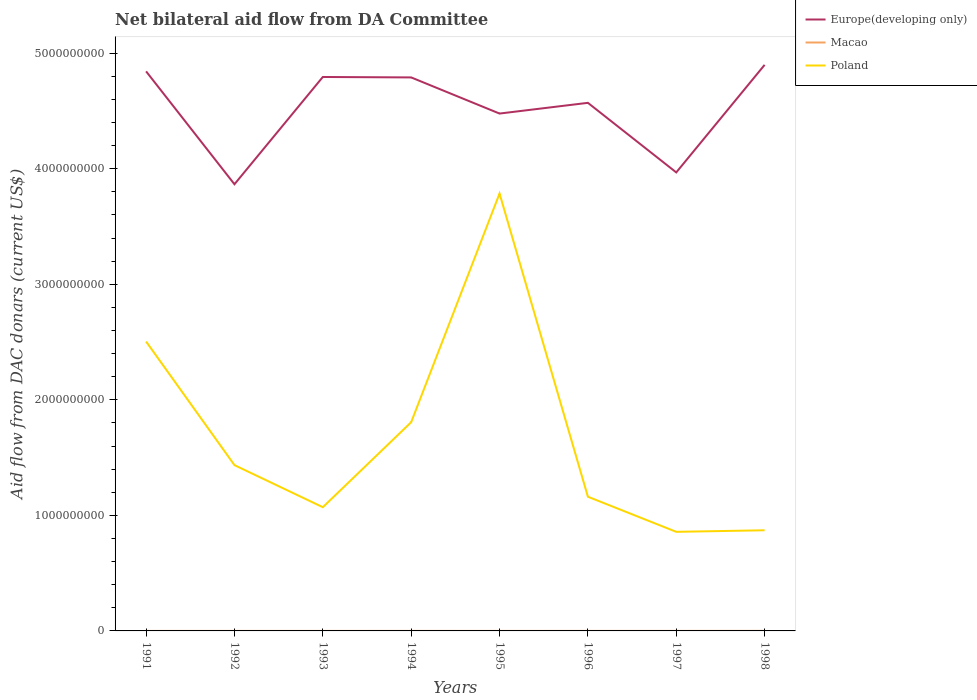How many different coloured lines are there?
Ensure brevity in your answer.  3. Does the line corresponding to Europe(developing only) intersect with the line corresponding to Poland?
Your answer should be compact. No. Across all years, what is the maximum aid flow in in Macao?
Provide a succinct answer. 1.20e+05. In which year was the aid flow in in Poland maximum?
Your answer should be very brief. 1997. What is the total aid flow in in Poland in the graph?
Ensure brevity in your answer.  -1.98e+09. What is the difference between the highest and the second highest aid flow in in Europe(developing only)?
Give a very brief answer. 1.03e+09. How many years are there in the graph?
Keep it short and to the point. 8. Are the values on the major ticks of Y-axis written in scientific E-notation?
Provide a short and direct response. No. Does the graph contain grids?
Give a very brief answer. No. How many legend labels are there?
Keep it short and to the point. 3. How are the legend labels stacked?
Ensure brevity in your answer.  Vertical. What is the title of the graph?
Offer a terse response. Net bilateral aid flow from DA Committee. Does "Bolivia" appear as one of the legend labels in the graph?
Your response must be concise. No. What is the label or title of the X-axis?
Your answer should be compact. Years. What is the label or title of the Y-axis?
Offer a very short reply. Aid flow from DAC donars (current US$). What is the Aid flow from DAC donars (current US$) in Europe(developing only) in 1991?
Provide a short and direct response. 4.84e+09. What is the Aid flow from DAC donars (current US$) in Poland in 1991?
Offer a very short reply. 2.50e+09. What is the Aid flow from DAC donars (current US$) in Europe(developing only) in 1992?
Keep it short and to the point. 3.87e+09. What is the Aid flow from DAC donars (current US$) in Macao in 1992?
Your answer should be very brief. 1.20e+05. What is the Aid flow from DAC donars (current US$) of Poland in 1992?
Give a very brief answer. 1.43e+09. What is the Aid flow from DAC donars (current US$) in Europe(developing only) in 1993?
Keep it short and to the point. 4.79e+09. What is the Aid flow from DAC donars (current US$) of Macao in 1993?
Keep it short and to the point. 1.50e+05. What is the Aid flow from DAC donars (current US$) of Poland in 1993?
Provide a succinct answer. 1.07e+09. What is the Aid flow from DAC donars (current US$) in Europe(developing only) in 1994?
Provide a succinct answer. 4.79e+09. What is the Aid flow from DAC donars (current US$) in Poland in 1994?
Provide a succinct answer. 1.81e+09. What is the Aid flow from DAC donars (current US$) in Europe(developing only) in 1995?
Provide a succinct answer. 4.48e+09. What is the Aid flow from DAC donars (current US$) of Poland in 1995?
Your answer should be very brief. 3.78e+09. What is the Aid flow from DAC donars (current US$) of Europe(developing only) in 1996?
Ensure brevity in your answer.  4.57e+09. What is the Aid flow from DAC donars (current US$) of Poland in 1996?
Keep it short and to the point. 1.16e+09. What is the Aid flow from DAC donars (current US$) in Europe(developing only) in 1997?
Your answer should be very brief. 3.97e+09. What is the Aid flow from DAC donars (current US$) of Poland in 1997?
Provide a short and direct response. 8.57e+08. What is the Aid flow from DAC donars (current US$) of Europe(developing only) in 1998?
Keep it short and to the point. 4.90e+09. What is the Aid flow from DAC donars (current US$) of Macao in 1998?
Keep it short and to the point. 5.00e+05. What is the Aid flow from DAC donars (current US$) in Poland in 1998?
Provide a succinct answer. 8.71e+08. Across all years, what is the maximum Aid flow from DAC donars (current US$) in Europe(developing only)?
Your answer should be very brief. 4.90e+09. Across all years, what is the maximum Aid flow from DAC donars (current US$) of Poland?
Your answer should be compact. 3.78e+09. Across all years, what is the minimum Aid flow from DAC donars (current US$) in Europe(developing only)?
Your response must be concise. 3.87e+09. Across all years, what is the minimum Aid flow from DAC donars (current US$) of Poland?
Give a very brief answer. 8.57e+08. What is the total Aid flow from DAC donars (current US$) in Europe(developing only) in the graph?
Offer a terse response. 3.62e+1. What is the total Aid flow from DAC donars (current US$) of Macao in the graph?
Ensure brevity in your answer.  1.90e+06. What is the total Aid flow from DAC donars (current US$) in Poland in the graph?
Ensure brevity in your answer.  1.35e+1. What is the difference between the Aid flow from DAC donars (current US$) of Europe(developing only) in 1991 and that in 1992?
Provide a succinct answer. 9.77e+08. What is the difference between the Aid flow from DAC donars (current US$) in Poland in 1991 and that in 1992?
Your answer should be compact. 1.07e+09. What is the difference between the Aid flow from DAC donars (current US$) in Europe(developing only) in 1991 and that in 1993?
Your response must be concise. 4.87e+07. What is the difference between the Aid flow from DAC donars (current US$) of Poland in 1991 and that in 1993?
Provide a short and direct response. 1.43e+09. What is the difference between the Aid flow from DAC donars (current US$) of Europe(developing only) in 1991 and that in 1994?
Ensure brevity in your answer.  5.25e+07. What is the difference between the Aid flow from DAC donars (current US$) in Macao in 1991 and that in 1994?
Ensure brevity in your answer.  -1.50e+05. What is the difference between the Aid flow from DAC donars (current US$) in Poland in 1991 and that in 1994?
Your answer should be very brief. 6.98e+08. What is the difference between the Aid flow from DAC donars (current US$) in Europe(developing only) in 1991 and that in 1995?
Make the answer very short. 3.65e+08. What is the difference between the Aid flow from DAC donars (current US$) of Poland in 1991 and that in 1995?
Give a very brief answer. -1.28e+09. What is the difference between the Aid flow from DAC donars (current US$) of Europe(developing only) in 1991 and that in 1996?
Make the answer very short. 2.72e+08. What is the difference between the Aid flow from DAC donars (current US$) in Poland in 1991 and that in 1996?
Offer a terse response. 1.34e+09. What is the difference between the Aid flow from DAC donars (current US$) of Europe(developing only) in 1991 and that in 1997?
Give a very brief answer. 8.74e+08. What is the difference between the Aid flow from DAC donars (current US$) of Macao in 1991 and that in 1997?
Your answer should be compact. -1.90e+05. What is the difference between the Aid flow from DAC donars (current US$) in Poland in 1991 and that in 1997?
Offer a terse response. 1.65e+09. What is the difference between the Aid flow from DAC donars (current US$) of Europe(developing only) in 1991 and that in 1998?
Provide a short and direct response. -5.60e+07. What is the difference between the Aid flow from DAC donars (current US$) in Macao in 1991 and that in 1998?
Provide a short and direct response. -3.80e+05. What is the difference between the Aid flow from DAC donars (current US$) of Poland in 1991 and that in 1998?
Ensure brevity in your answer.  1.63e+09. What is the difference between the Aid flow from DAC donars (current US$) of Europe(developing only) in 1992 and that in 1993?
Provide a succinct answer. -9.28e+08. What is the difference between the Aid flow from DAC donars (current US$) in Macao in 1992 and that in 1993?
Offer a terse response. -3.00e+04. What is the difference between the Aid flow from DAC donars (current US$) of Poland in 1992 and that in 1993?
Make the answer very short. 3.64e+08. What is the difference between the Aid flow from DAC donars (current US$) of Europe(developing only) in 1992 and that in 1994?
Your answer should be very brief. -9.24e+08. What is the difference between the Aid flow from DAC donars (current US$) in Poland in 1992 and that in 1994?
Your answer should be very brief. -3.72e+08. What is the difference between the Aid flow from DAC donars (current US$) of Europe(developing only) in 1992 and that in 1995?
Your answer should be compact. -6.12e+08. What is the difference between the Aid flow from DAC donars (current US$) in Macao in 1992 and that in 1995?
Give a very brief answer. -2.00e+04. What is the difference between the Aid flow from DAC donars (current US$) in Poland in 1992 and that in 1995?
Offer a terse response. -2.35e+09. What is the difference between the Aid flow from DAC donars (current US$) in Europe(developing only) in 1992 and that in 1996?
Provide a succinct answer. -7.04e+08. What is the difference between the Aid flow from DAC donars (current US$) in Macao in 1992 and that in 1996?
Your answer should be very brief. -1.70e+05. What is the difference between the Aid flow from DAC donars (current US$) in Poland in 1992 and that in 1996?
Make the answer very short. 2.73e+08. What is the difference between the Aid flow from DAC donars (current US$) in Europe(developing only) in 1992 and that in 1997?
Your answer should be compact. -1.02e+08. What is the difference between the Aid flow from DAC donars (current US$) of Poland in 1992 and that in 1997?
Your answer should be compact. 5.77e+08. What is the difference between the Aid flow from DAC donars (current US$) of Europe(developing only) in 1992 and that in 1998?
Your answer should be very brief. -1.03e+09. What is the difference between the Aid flow from DAC donars (current US$) of Macao in 1992 and that in 1998?
Keep it short and to the point. -3.80e+05. What is the difference between the Aid flow from DAC donars (current US$) in Poland in 1992 and that in 1998?
Make the answer very short. 5.64e+08. What is the difference between the Aid flow from DAC donars (current US$) of Europe(developing only) in 1993 and that in 1994?
Provide a short and direct response. 3.82e+06. What is the difference between the Aid flow from DAC donars (current US$) of Poland in 1993 and that in 1994?
Give a very brief answer. -7.36e+08. What is the difference between the Aid flow from DAC donars (current US$) of Europe(developing only) in 1993 and that in 1995?
Your answer should be compact. 3.16e+08. What is the difference between the Aid flow from DAC donars (current US$) of Poland in 1993 and that in 1995?
Your response must be concise. -2.71e+09. What is the difference between the Aid flow from DAC donars (current US$) of Europe(developing only) in 1993 and that in 1996?
Provide a short and direct response. 2.24e+08. What is the difference between the Aid flow from DAC donars (current US$) of Macao in 1993 and that in 1996?
Your answer should be very brief. -1.40e+05. What is the difference between the Aid flow from DAC donars (current US$) in Poland in 1993 and that in 1996?
Make the answer very short. -9.06e+07. What is the difference between the Aid flow from DAC donars (current US$) of Europe(developing only) in 1993 and that in 1997?
Offer a terse response. 8.26e+08. What is the difference between the Aid flow from DAC donars (current US$) of Macao in 1993 and that in 1997?
Make the answer very short. -1.60e+05. What is the difference between the Aid flow from DAC donars (current US$) of Poland in 1993 and that in 1997?
Keep it short and to the point. 2.13e+08. What is the difference between the Aid flow from DAC donars (current US$) in Europe(developing only) in 1993 and that in 1998?
Your answer should be very brief. -1.05e+08. What is the difference between the Aid flow from DAC donars (current US$) of Macao in 1993 and that in 1998?
Provide a short and direct response. -3.50e+05. What is the difference between the Aid flow from DAC donars (current US$) in Poland in 1993 and that in 1998?
Give a very brief answer. 2.00e+08. What is the difference between the Aid flow from DAC donars (current US$) of Europe(developing only) in 1994 and that in 1995?
Your answer should be compact. 3.13e+08. What is the difference between the Aid flow from DAC donars (current US$) of Macao in 1994 and that in 1995?
Offer a terse response. 1.30e+05. What is the difference between the Aid flow from DAC donars (current US$) of Poland in 1994 and that in 1995?
Give a very brief answer. -1.98e+09. What is the difference between the Aid flow from DAC donars (current US$) in Europe(developing only) in 1994 and that in 1996?
Make the answer very short. 2.20e+08. What is the difference between the Aid flow from DAC donars (current US$) of Poland in 1994 and that in 1996?
Your response must be concise. 6.45e+08. What is the difference between the Aid flow from DAC donars (current US$) of Europe(developing only) in 1994 and that in 1997?
Your answer should be very brief. 8.22e+08. What is the difference between the Aid flow from DAC donars (current US$) of Poland in 1994 and that in 1997?
Provide a succinct answer. 9.49e+08. What is the difference between the Aid flow from DAC donars (current US$) in Europe(developing only) in 1994 and that in 1998?
Keep it short and to the point. -1.09e+08. What is the difference between the Aid flow from DAC donars (current US$) of Poland in 1994 and that in 1998?
Make the answer very short. 9.35e+08. What is the difference between the Aid flow from DAC donars (current US$) of Europe(developing only) in 1995 and that in 1996?
Your response must be concise. -9.28e+07. What is the difference between the Aid flow from DAC donars (current US$) of Poland in 1995 and that in 1996?
Offer a terse response. 2.62e+09. What is the difference between the Aid flow from DAC donars (current US$) of Europe(developing only) in 1995 and that in 1997?
Provide a succinct answer. 5.09e+08. What is the difference between the Aid flow from DAC donars (current US$) of Poland in 1995 and that in 1997?
Ensure brevity in your answer.  2.93e+09. What is the difference between the Aid flow from DAC donars (current US$) of Europe(developing only) in 1995 and that in 1998?
Provide a succinct answer. -4.21e+08. What is the difference between the Aid flow from DAC donars (current US$) of Macao in 1995 and that in 1998?
Provide a short and direct response. -3.60e+05. What is the difference between the Aid flow from DAC donars (current US$) in Poland in 1995 and that in 1998?
Make the answer very short. 2.91e+09. What is the difference between the Aid flow from DAC donars (current US$) in Europe(developing only) in 1996 and that in 1997?
Your answer should be compact. 6.02e+08. What is the difference between the Aid flow from DAC donars (current US$) of Poland in 1996 and that in 1997?
Provide a short and direct response. 3.04e+08. What is the difference between the Aid flow from DAC donars (current US$) of Europe(developing only) in 1996 and that in 1998?
Provide a short and direct response. -3.28e+08. What is the difference between the Aid flow from DAC donars (current US$) of Poland in 1996 and that in 1998?
Provide a succinct answer. 2.90e+08. What is the difference between the Aid flow from DAC donars (current US$) of Europe(developing only) in 1997 and that in 1998?
Your answer should be very brief. -9.30e+08. What is the difference between the Aid flow from DAC donars (current US$) in Macao in 1997 and that in 1998?
Offer a terse response. -1.90e+05. What is the difference between the Aid flow from DAC donars (current US$) in Poland in 1997 and that in 1998?
Give a very brief answer. -1.35e+07. What is the difference between the Aid flow from DAC donars (current US$) in Europe(developing only) in 1991 and the Aid flow from DAC donars (current US$) in Macao in 1992?
Ensure brevity in your answer.  4.84e+09. What is the difference between the Aid flow from DAC donars (current US$) of Europe(developing only) in 1991 and the Aid flow from DAC donars (current US$) of Poland in 1992?
Offer a terse response. 3.41e+09. What is the difference between the Aid flow from DAC donars (current US$) of Macao in 1991 and the Aid flow from DAC donars (current US$) of Poland in 1992?
Make the answer very short. -1.43e+09. What is the difference between the Aid flow from DAC donars (current US$) in Europe(developing only) in 1991 and the Aid flow from DAC donars (current US$) in Macao in 1993?
Provide a short and direct response. 4.84e+09. What is the difference between the Aid flow from DAC donars (current US$) of Europe(developing only) in 1991 and the Aid flow from DAC donars (current US$) of Poland in 1993?
Provide a short and direct response. 3.77e+09. What is the difference between the Aid flow from DAC donars (current US$) of Macao in 1991 and the Aid flow from DAC donars (current US$) of Poland in 1993?
Your answer should be very brief. -1.07e+09. What is the difference between the Aid flow from DAC donars (current US$) in Europe(developing only) in 1991 and the Aid flow from DAC donars (current US$) in Macao in 1994?
Your answer should be very brief. 4.84e+09. What is the difference between the Aid flow from DAC donars (current US$) in Europe(developing only) in 1991 and the Aid flow from DAC donars (current US$) in Poland in 1994?
Offer a terse response. 3.04e+09. What is the difference between the Aid flow from DAC donars (current US$) in Macao in 1991 and the Aid flow from DAC donars (current US$) in Poland in 1994?
Offer a terse response. -1.81e+09. What is the difference between the Aid flow from DAC donars (current US$) in Europe(developing only) in 1991 and the Aid flow from DAC donars (current US$) in Macao in 1995?
Your answer should be very brief. 4.84e+09. What is the difference between the Aid flow from DAC donars (current US$) in Europe(developing only) in 1991 and the Aid flow from DAC donars (current US$) in Poland in 1995?
Your answer should be compact. 1.06e+09. What is the difference between the Aid flow from DAC donars (current US$) of Macao in 1991 and the Aid flow from DAC donars (current US$) of Poland in 1995?
Give a very brief answer. -3.78e+09. What is the difference between the Aid flow from DAC donars (current US$) in Europe(developing only) in 1991 and the Aid flow from DAC donars (current US$) in Macao in 1996?
Your answer should be compact. 4.84e+09. What is the difference between the Aid flow from DAC donars (current US$) of Europe(developing only) in 1991 and the Aid flow from DAC donars (current US$) of Poland in 1996?
Offer a very short reply. 3.68e+09. What is the difference between the Aid flow from DAC donars (current US$) of Macao in 1991 and the Aid flow from DAC donars (current US$) of Poland in 1996?
Make the answer very short. -1.16e+09. What is the difference between the Aid flow from DAC donars (current US$) of Europe(developing only) in 1991 and the Aid flow from DAC donars (current US$) of Macao in 1997?
Your answer should be very brief. 4.84e+09. What is the difference between the Aid flow from DAC donars (current US$) of Europe(developing only) in 1991 and the Aid flow from DAC donars (current US$) of Poland in 1997?
Provide a succinct answer. 3.98e+09. What is the difference between the Aid flow from DAC donars (current US$) of Macao in 1991 and the Aid flow from DAC donars (current US$) of Poland in 1997?
Make the answer very short. -8.57e+08. What is the difference between the Aid flow from DAC donars (current US$) of Europe(developing only) in 1991 and the Aid flow from DAC donars (current US$) of Macao in 1998?
Your answer should be very brief. 4.84e+09. What is the difference between the Aid flow from DAC donars (current US$) in Europe(developing only) in 1991 and the Aid flow from DAC donars (current US$) in Poland in 1998?
Offer a very short reply. 3.97e+09. What is the difference between the Aid flow from DAC donars (current US$) of Macao in 1991 and the Aid flow from DAC donars (current US$) of Poland in 1998?
Provide a succinct answer. -8.71e+08. What is the difference between the Aid flow from DAC donars (current US$) of Europe(developing only) in 1992 and the Aid flow from DAC donars (current US$) of Macao in 1993?
Give a very brief answer. 3.87e+09. What is the difference between the Aid flow from DAC donars (current US$) in Europe(developing only) in 1992 and the Aid flow from DAC donars (current US$) in Poland in 1993?
Make the answer very short. 2.79e+09. What is the difference between the Aid flow from DAC donars (current US$) of Macao in 1992 and the Aid flow from DAC donars (current US$) of Poland in 1993?
Your response must be concise. -1.07e+09. What is the difference between the Aid flow from DAC donars (current US$) in Europe(developing only) in 1992 and the Aid flow from DAC donars (current US$) in Macao in 1994?
Give a very brief answer. 3.86e+09. What is the difference between the Aid flow from DAC donars (current US$) in Europe(developing only) in 1992 and the Aid flow from DAC donars (current US$) in Poland in 1994?
Provide a succinct answer. 2.06e+09. What is the difference between the Aid flow from DAC donars (current US$) in Macao in 1992 and the Aid flow from DAC donars (current US$) in Poland in 1994?
Provide a succinct answer. -1.81e+09. What is the difference between the Aid flow from DAC donars (current US$) of Europe(developing only) in 1992 and the Aid flow from DAC donars (current US$) of Macao in 1995?
Your response must be concise. 3.87e+09. What is the difference between the Aid flow from DAC donars (current US$) of Europe(developing only) in 1992 and the Aid flow from DAC donars (current US$) of Poland in 1995?
Your answer should be very brief. 8.05e+07. What is the difference between the Aid flow from DAC donars (current US$) in Macao in 1992 and the Aid flow from DAC donars (current US$) in Poland in 1995?
Ensure brevity in your answer.  -3.78e+09. What is the difference between the Aid flow from DAC donars (current US$) of Europe(developing only) in 1992 and the Aid flow from DAC donars (current US$) of Macao in 1996?
Make the answer very short. 3.86e+09. What is the difference between the Aid flow from DAC donars (current US$) of Europe(developing only) in 1992 and the Aid flow from DAC donars (current US$) of Poland in 1996?
Offer a terse response. 2.70e+09. What is the difference between the Aid flow from DAC donars (current US$) of Macao in 1992 and the Aid flow from DAC donars (current US$) of Poland in 1996?
Your answer should be compact. -1.16e+09. What is the difference between the Aid flow from DAC donars (current US$) in Europe(developing only) in 1992 and the Aid flow from DAC donars (current US$) in Macao in 1997?
Offer a very short reply. 3.86e+09. What is the difference between the Aid flow from DAC donars (current US$) of Europe(developing only) in 1992 and the Aid flow from DAC donars (current US$) of Poland in 1997?
Ensure brevity in your answer.  3.01e+09. What is the difference between the Aid flow from DAC donars (current US$) of Macao in 1992 and the Aid flow from DAC donars (current US$) of Poland in 1997?
Ensure brevity in your answer.  -8.57e+08. What is the difference between the Aid flow from DAC donars (current US$) of Europe(developing only) in 1992 and the Aid flow from DAC donars (current US$) of Macao in 1998?
Your response must be concise. 3.86e+09. What is the difference between the Aid flow from DAC donars (current US$) in Europe(developing only) in 1992 and the Aid flow from DAC donars (current US$) in Poland in 1998?
Keep it short and to the point. 2.99e+09. What is the difference between the Aid flow from DAC donars (current US$) in Macao in 1992 and the Aid flow from DAC donars (current US$) in Poland in 1998?
Offer a terse response. -8.71e+08. What is the difference between the Aid flow from DAC donars (current US$) in Europe(developing only) in 1993 and the Aid flow from DAC donars (current US$) in Macao in 1994?
Offer a very short reply. 4.79e+09. What is the difference between the Aid flow from DAC donars (current US$) of Europe(developing only) in 1993 and the Aid flow from DAC donars (current US$) of Poland in 1994?
Your response must be concise. 2.99e+09. What is the difference between the Aid flow from DAC donars (current US$) in Macao in 1993 and the Aid flow from DAC donars (current US$) in Poland in 1994?
Offer a very short reply. -1.81e+09. What is the difference between the Aid flow from DAC donars (current US$) of Europe(developing only) in 1993 and the Aid flow from DAC donars (current US$) of Macao in 1995?
Your response must be concise. 4.79e+09. What is the difference between the Aid flow from DAC donars (current US$) in Europe(developing only) in 1993 and the Aid flow from DAC donars (current US$) in Poland in 1995?
Ensure brevity in your answer.  1.01e+09. What is the difference between the Aid flow from DAC donars (current US$) of Macao in 1993 and the Aid flow from DAC donars (current US$) of Poland in 1995?
Provide a succinct answer. -3.78e+09. What is the difference between the Aid flow from DAC donars (current US$) in Europe(developing only) in 1993 and the Aid flow from DAC donars (current US$) in Macao in 1996?
Give a very brief answer. 4.79e+09. What is the difference between the Aid flow from DAC donars (current US$) in Europe(developing only) in 1993 and the Aid flow from DAC donars (current US$) in Poland in 1996?
Keep it short and to the point. 3.63e+09. What is the difference between the Aid flow from DAC donars (current US$) in Macao in 1993 and the Aid flow from DAC donars (current US$) in Poland in 1996?
Give a very brief answer. -1.16e+09. What is the difference between the Aid flow from DAC donars (current US$) in Europe(developing only) in 1993 and the Aid flow from DAC donars (current US$) in Macao in 1997?
Provide a succinct answer. 4.79e+09. What is the difference between the Aid flow from DAC donars (current US$) in Europe(developing only) in 1993 and the Aid flow from DAC donars (current US$) in Poland in 1997?
Give a very brief answer. 3.94e+09. What is the difference between the Aid flow from DAC donars (current US$) of Macao in 1993 and the Aid flow from DAC donars (current US$) of Poland in 1997?
Keep it short and to the point. -8.57e+08. What is the difference between the Aid flow from DAC donars (current US$) in Europe(developing only) in 1993 and the Aid flow from DAC donars (current US$) in Macao in 1998?
Provide a short and direct response. 4.79e+09. What is the difference between the Aid flow from DAC donars (current US$) in Europe(developing only) in 1993 and the Aid flow from DAC donars (current US$) in Poland in 1998?
Offer a very short reply. 3.92e+09. What is the difference between the Aid flow from DAC donars (current US$) of Macao in 1993 and the Aid flow from DAC donars (current US$) of Poland in 1998?
Keep it short and to the point. -8.71e+08. What is the difference between the Aid flow from DAC donars (current US$) of Europe(developing only) in 1994 and the Aid flow from DAC donars (current US$) of Macao in 1995?
Your answer should be compact. 4.79e+09. What is the difference between the Aid flow from DAC donars (current US$) in Europe(developing only) in 1994 and the Aid flow from DAC donars (current US$) in Poland in 1995?
Your answer should be compact. 1.00e+09. What is the difference between the Aid flow from DAC donars (current US$) in Macao in 1994 and the Aid flow from DAC donars (current US$) in Poland in 1995?
Keep it short and to the point. -3.78e+09. What is the difference between the Aid flow from DAC donars (current US$) in Europe(developing only) in 1994 and the Aid flow from DAC donars (current US$) in Macao in 1996?
Your answer should be compact. 4.79e+09. What is the difference between the Aid flow from DAC donars (current US$) of Europe(developing only) in 1994 and the Aid flow from DAC donars (current US$) of Poland in 1996?
Give a very brief answer. 3.63e+09. What is the difference between the Aid flow from DAC donars (current US$) of Macao in 1994 and the Aid flow from DAC donars (current US$) of Poland in 1996?
Provide a short and direct response. -1.16e+09. What is the difference between the Aid flow from DAC donars (current US$) in Europe(developing only) in 1994 and the Aid flow from DAC donars (current US$) in Macao in 1997?
Your response must be concise. 4.79e+09. What is the difference between the Aid flow from DAC donars (current US$) of Europe(developing only) in 1994 and the Aid flow from DAC donars (current US$) of Poland in 1997?
Your answer should be very brief. 3.93e+09. What is the difference between the Aid flow from DAC donars (current US$) in Macao in 1994 and the Aid flow from DAC donars (current US$) in Poland in 1997?
Provide a succinct answer. -8.57e+08. What is the difference between the Aid flow from DAC donars (current US$) of Europe(developing only) in 1994 and the Aid flow from DAC donars (current US$) of Macao in 1998?
Your answer should be very brief. 4.79e+09. What is the difference between the Aid flow from DAC donars (current US$) in Europe(developing only) in 1994 and the Aid flow from DAC donars (current US$) in Poland in 1998?
Your answer should be compact. 3.92e+09. What is the difference between the Aid flow from DAC donars (current US$) of Macao in 1994 and the Aid flow from DAC donars (current US$) of Poland in 1998?
Your answer should be compact. -8.71e+08. What is the difference between the Aid flow from DAC donars (current US$) in Europe(developing only) in 1995 and the Aid flow from DAC donars (current US$) in Macao in 1996?
Give a very brief answer. 4.48e+09. What is the difference between the Aid flow from DAC donars (current US$) of Europe(developing only) in 1995 and the Aid flow from DAC donars (current US$) of Poland in 1996?
Offer a terse response. 3.32e+09. What is the difference between the Aid flow from DAC donars (current US$) of Macao in 1995 and the Aid flow from DAC donars (current US$) of Poland in 1996?
Keep it short and to the point. -1.16e+09. What is the difference between the Aid flow from DAC donars (current US$) of Europe(developing only) in 1995 and the Aid flow from DAC donars (current US$) of Macao in 1997?
Offer a terse response. 4.48e+09. What is the difference between the Aid flow from DAC donars (current US$) in Europe(developing only) in 1995 and the Aid flow from DAC donars (current US$) in Poland in 1997?
Give a very brief answer. 3.62e+09. What is the difference between the Aid flow from DAC donars (current US$) of Macao in 1995 and the Aid flow from DAC donars (current US$) of Poland in 1997?
Ensure brevity in your answer.  -8.57e+08. What is the difference between the Aid flow from DAC donars (current US$) of Europe(developing only) in 1995 and the Aid flow from DAC donars (current US$) of Macao in 1998?
Make the answer very short. 4.48e+09. What is the difference between the Aid flow from DAC donars (current US$) of Europe(developing only) in 1995 and the Aid flow from DAC donars (current US$) of Poland in 1998?
Your answer should be compact. 3.61e+09. What is the difference between the Aid flow from DAC donars (current US$) in Macao in 1995 and the Aid flow from DAC donars (current US$) in Poland in 1998?
Keep it short and to the point. -8.71e+08. What is the difference between the Aid flow from DAC donars (current US$) of Europe(developing only) in 1996 and the Aid flow from DAC donars (current US$) of Macao in 1997?
Offer a terse response. 4.57e+09. What is the difference between the Aid flow from DAC donars (current US$) of Europe(developing only) in 1996 and the Aid flow from DAC donars (current US$) of Poland in 1997?
Ensure brevity in your answer.  3.71e+09. What is the difference between the Aid flow from DAC donars (current US$) of Macao in 1996 and the Aid flow from DAC donars (current US$) of Poland in 1997?
Your answer should be compact. -8.57e+08. What is the difference between the Aid flow from DAC donars (current US$) in Europe(developing only) in 1996 and the Aid flow from DAC donars (current US$) in Macao in 1998?
Provide a succinct answer. 4.57e+09. What is the difference between the Aid flow from DAC donars (current US$) of Europe(developing only) in 1996 and the Aid flow from DAC donars (current US$) of Poland in 1998?
Your answer should be very brief. 3.70e+09. What is the difference between the Aid flow from DAC donars (current US$) of Macao in 1996 and the Aid flow from DAC donars (current US$) of Poland in 1998?
Make the answer very short. -8.71e+08. What is the difference between the Aid flow from DAC donars (current US$) in Europe(developing only) in 1997 and the Aid flow from DAC donars (current US$) in Macao in 1998?
Offer a very short reply. 3.97e+09. What is the difference between the Aid flow from DAC donars (current US$) of Europe(developing only) in 1997 and the Aid flow from DAC donars (current US$) of Poland in 1998?
Your answer should be very brief. 3.10e+09. What is the difference between the Aid flow from DAC donars (current US$) in Macao in 1997 and the Aid flow from DAC donars (current US$) in Poland in 1998?
Your response must be concise. -8.71e+08. What is the average Aid flow from DAC donars (current US$) in Europe(developing only) per year?
Your answer should be very brief. 4.53e+09. What is the average Aid flow from DAC donars (current US$) in Macao per year?
Your answer should be very brief. 2.38e+05. What is the average Aid flow from DAC donars (current US$) of Poland per year?
Provide a succinct answer. 1.69e+09. In the year 1991, what is the difference between the Aid flow from DAC donars (current US$) of Europe(developing only) and Aid flow from DAC donars (current US$) of Macao?
Provide a short and direct response. 4.84e+09. In the year 1991, what is the difference between the Aid flow from DAC donars (current US$) of Europe(developing only) and Aid flow from DAC donars (current US$) of Poland?
Offer a very short reply. 2.34e+09. In the year 1991, what is the difference between the Aid flow from DAC donars (current US$) of Macao and Aid flow from DAC donars (current US$) of Poland?
Provide a succinct answer. -2.50e+09. In the year 1992, what is the difference between the Aid flow from DAC donars (current US$) in Europe(developing only) and Aid flow from DAC donars (current US$) in Macao?
Provide a succinct answer. 3.87e+09. In the year 1992, what is the difference between the Aid flow from DAC donars (current US$) of Europe(developing only) and Aid flow from DAC donars (current US$) of Poland?
Keep it short and to the point. 2.43e+09. In the year 1992, what is the difference between the Aid flow from DAC donars (current US$) in Macao and Aid flow from DAC donars (current US$) in Poland?
Your answer should be very brief. -1.43e+09. In the year 1993, what is the difference between the Aid flow from DAC donars (current US$) in Europe(developing only) and Aid flow from DAC donars (current US$) in Macao?
Provide a succinct answer. 4.79e+09. In the year 1993, what is the difference between the Aid flow from DAC donars (current US$) in Europe(developing only) and Aid flow from DAC donars (current US$) in Poland?
Keep it short and to the point. 3.72e+09. In the year 1993, what is the difference between the Aid flow from DAC donars (current US$) of Macao and Aid flow from DAC donars (current US$) of Poland?
Your answer should be very brief. -1.07e+09. In the year 1994, what is the difference between the Aid flow from DAC donars (current US$) of Europe(developing only) and Aid flow from DAC donars (current US$) of Macao?
Keep it short and to the point. 4.79e+09. In the year 1994, what is the difference between the Aid flow from DAC donars (current US$) in Europe(developing only) and Aid flow from DAC donars (current US$) in Poland?
Make the answer very short. 2.98e+09. In the year 1994, what is the difference between the Aid flow from DAC donars (current US$) of Macao and Aid flow from DAC donars (current US$) of Poland?
Offer a terse response. -1.81e+09. In the year 1995, what is the difference between the Aid flow from DAC donars (current US$) of Europe(developing only) and Aid flow from DAC donars (current US$) of Macao?
Keep it short and to the point. 4.48e+09. In the year 1995, what is the difference between the Aid flow from DAC donars (current US$) in Europe(developing only) and Aid flow from DAC donars (current US$) in Poland?
Your response must be concise. 6.92e+08. In the year 1995, what is the difference between the Aid flow from DAC donars (current US$) in Macao and Aid flow from DAC donars (current US$) in Poland?
Your answer should be very brief. -3.78e+09. In the year 1996, what is the difference between the Aid flow from DAC donars (current US$) in Europe(developing only) and Aid flow from DAC donars (current US$) in Macao?
Keep it short and to the point. 4.57e+09. In the year 1996, what is the difference between the Aid flow from DAC donars (current US$) in Europe(developing only) and Aid flow from DAC donars (current US$) in Poland?
Offer a terse response. 3.41e+09. In the year 1996, what is the difference between the Aid flow from DAC donars (current US$) in Macao and Aid flow from DAC donars (current US$) in Poland?
Make the answer very short. -1.16e+09. In the year 1997, what is the difference between the Aid flow from DAC donars (current US$) of Europe(developing only) and Aid flow from DAC donars (current US$) of Macao?
Provide a succinct answer. 3.97e+09. In the year 1997, what is the difference between the Aid flow from DAC donars (current US$) in Europe(developing only) and Aid flow from DAC donars (current US$) in Poland?
Make the answer very short. 3.11e+09. In the year 1997, what is the difference between the Aid flow from DAC donars (current US$) of Macao and Aid flow from DAC donars (current US$) of Poland?
Offer a terse response. -8.57e+08. In the year 1998, what is the difference between the Aid flow from DAC donars (current US$) in Europe(developing only) and Aid flow from DAC donars (current US$) in Macao?
Ensure brevity in your answer.  4.90e+09. In the year 1998, what is the difference between the Aid flow from DAC donars (current US$) in Europe(developing only) and Aid flow from DAC donars (current US$) in Poland?
Give a very brief answer. 4.03e+09. In the year 1998, what is the difference between the Aid flow from DAC donars (current US$) in Macao and Aid flow from DAC donars (current US$) in Poland?
Ensure brevity in your answer.  -8.70e+08. What is the ratio of the Aid flow from DAC donars (current US$) of Europe(developing only) in 1991 to that in 1992?
Offer a very short reply. 1.25. What is the ratio of the Aid flow from DAC donars (current US$) of Poland in 1991 to that in 1992?
Give a very brief answer. 1.75. What is the ratio of the Aid flow from DAC donars (current US$) in Europe(developing only) in 1991 to that in 1993?
Make the answer very short. 1.01. What is the ratio of the Aid flow from DAC donars (current US$) in Macao in 1991 to that in 1993?
Your answer should be compact. 0.8. What is the ratio of the Aid flow from DAC donars (current US$) in Poland in 1991 to that in 1993?
Keep it short and to the point. 2.34. What is the ratio of the Aid flow from DAC donars (current US$) in Europe(developing only) in 1991 to that in 1994?
Offer a terse response. 1.01. What is the ratio of the Aid flow from DAC donars (current US$) in Macao in 1991 to that in 1994?
Ensure brevity in your answer.  0.44. What is the ratio of the Aid flow from DAC donars (current US$) in Poland in 1991 to that in 1994?
Offer a terse response. 1.39. What is the ratio of the Aid flow from DAC donars (current US$) of Europe(developing only) in 1991 to that in 1995?
Give a very brief answer. 1.08. What is the ratio of the Aid flow from DAC donars (current US$) in Macao in 1991 to that in 1995?
Give a very brief answer. 0.86. What is the ratio of the Aid flow from DAC donars (current US$) in Poland in 1991 to that in 1995?
Make the answer very short. 0.66. What is the ratio of the Aid flow from DAC donars (current US$) in Europe(developing only) in 1991 to that in 1996?
Ensure brevity in your answer.  1.06. What is the ratio of the Aid flow from DAC donars (current US$) in Macao in 1991 to that in 1996?
Provide a succinct answer. 0.41. What is the ratio of the Aid flow from DAC donars (current US$) in Poland in 1991 to that in 1996?
Keep it short and to the point. 2.16. What is the ratio of the Aid flow from DAC donars (current US$) of Europe(developing only) in 1991 to that in 1997?
Give a very brief answer. 1.22. What is the ratio of the Aid flow from DAC donars (current US$) in Macao in 1991 to that in 1997?
Keep it short and to the point. 0.39. What is the ratio of the Aid flow from DAC donars (current US$) of Poland in 1991 to that in 1997?
Provide a succinct answer. 2.92. What is the ratio of the Aid flow from DAC donars (current US$) of Europe(developing only) in 1991 to that in 1998?
Offer a very short reply. 0.99. What is the ratio of the Aid flow from DAC donars (current US$) in Macao in 1991 to that in 1998?
Your response must be concise. 0.24. What is the ratio of the Aid flow from DAC donars (current US$) in Poland in 1991 to that in 1998?
Your answer should be compact. 2.88. What is the ratio of the Aid flow from DAC donars (current US$) of Europe(developing only) in 1992 to that in 1993?
Keep it short and to the point. 0.81. What is the ratio of the Aid flow from DAC donars (current US$) of Macao in 1992 to that in 1993?
Ensure brevity in your answer.  0.8. What is the ratio of the Aid flow from DAC donars (current US$) in Poland in 1992 to that in 1993?
Make the answer very short. 1.34. What is the ratio of the Aid flow from DAC donars (current US$) of Europe(developing only) in 1992 to that in 1994?
Keep it short and to the point. 0.81. What is the ratio of the Aid flow from DAC donars (current US$) in Macao in 1992 to that in 1994?
Offer a terse response. 0.44. What is the ratio of the Aid flow from DAC donars (current US$) of Poland in 1992 to that in 1994?
Your answer should be compact. 0.79. What is the ratio of the Aid flow from DAC donars (current US$) of Europe(developing only) in 1992 to that in 1995?
Provide a succinct answer. 0.86. What is the ratio of the Aid flow from DAC donars (current US$) in Poland in 1992 to that in 1995?
Your answer should be compact. 0.38. What is the ratio of the Aid flow from DAC donars (current US$) of Europe(developing only) in 1992 to that in 1996?
Give a very brief answer. 0.85. What is the ratio of the Aid flow from DAC donars (current US$) of Macao in 1992 to that in 1996?
Make the answer very short. 0.41. What is the ratio of the Aid flow from DAC donars (current US$) in Poland in 1992 to that in 1996?
Keep it short and to the point. 1.24. What is the ratio of the Aid flow from DAC donars (current US$) in Europe(developing only) in 1992 to that in 1997?
Offer a terse response. 0.97. What is the ratio of the Aid flow from DAC donars (current US$) in Macao in 1992 to that in 1997?
Give a very brief answer. 0.39. What is the ratio of the Aid flow from DAC donars (current US$) in Poland in 1992 to that in 1997?
Give a very brief answer. 1.67. What is the ratio of the Aid flow from DAC donars (current US$) of Europe(developing only) in 1992 to that in 1998?
Provide a succinct answer. 0.79. What is the ratio of the Aid flow from DAC donars (current US$) of Macao in 1992 to that in 1998?
Give a very brief answer. 0.24. What is the ratio of the Aid flow from DAC donars (current US$) of Poland in 1992 to that in 1998?
Keep it short and to the point. 1.65. What is the ratio of the Aid flow from DAC donars (current US$) in Europe(developing only) in 1993 to that in 1994?
Keep it short and to the point. 1. What is the ratio of the Aid flow from DAC donars (current US$) in Macao in 1993 to that in 1994?
Ensure brevity in your answer.  0.56. What is the ratio of the Aid flow from DAC donars (current US$) in Poland in 1993 to that in 1994?
Offer a very short reply. 0.59. What is the ratio of the Aid flow from DAC donars (current US$) of Europe(developing only) in 1993 to that in 1995?
Your answer should be very brief. 1.07. What is the ratio of the Aid flow from DAC donars (current US$) in Macao in 1993 to that in 1995?
Keep it short and to the point. 1.07. What is the ratio of the Aid flow from DAC donars (current US$) of Poland in 1993 to that in 1995?
Provide a succinct answer. 0.28. What is the ratio of the Aid flow from DAC donars (current US$) in Europe(developing only) in 1993 to that in 1996?
Make the answer very short. 1.05. What is the ratio of the Aid flow from DAC donars (current US$) in Macao in 1993 to that in 1996?
Offer a terse response. 0.52. What is the ratio of the Aid flow from DAC donars (current US$) in Poland in 1993 to that in 1996?
Provide a succinct answer. 0.92. What is the ratio of the Aid flow from DAC donars (current US$) in Europe(developing only) in 1993 to that in 1997?
Ensure brevity in your answer.  1.21. What is the ratio of the Aid flow from DAC donars (current US$) in Macao in 1993 to that in 1997?
Your answer should be very brief. 0.48. What is the ratio of the Aid flow from DAC donars (current US$) in Poland in 1993 to that in 1997?
Ensure brevity in your answer.  1.25. What is the ratio of the Aid flow from DAC donars (current US$) of Europe(developing only) in 1993 to that in 1998?
Offer a very short reply. 0.98. What is the ratio of the Aid flow from DAC donars (current US$) of Poland in 1993 to that in 1998?
Your response must be concise. 1.23. What is the ratio of the Aid flow from DAC donars (current US$) of Europe(developing only) in 1994 to that in 1995?
Your response must be concise. 1.07. What is the ratio of the Aid flow from DAC donars (current US$) of Macao in 1994 to that in 1995?
Provide a short and direct response. 1.93. What is the ratio of the Aid flow from DAC donars (current US$) in Poland in 1994 to that in 1995?
Ensure brevity in your answer.  0.48. What is the ratio of the Aid flow from DAC donars (current US$) of Europe(developing only) in 1994 to that in 1996?
Offer a very short reply. 1.05. What is the ratio of the Aid flow from DAC donars (current US$) of Macao in 1994 to that in 1996?
Provide a succinct answer. 0.93. What is the ratio of the Aid flow from DAC donars (current US$) in Poland in 1994 to that in 1996?
Offer a terse response. 1.56. What is the ratio of the Aid flow from DAC donars (current US$) of Europe(developing only) in 1994 to that in 1997?
Ensure brevity in your answer.  1.21. What is the ratio of the Aid flow from DAC donars (current US$) of Macao in 1994 to that in 1997?
Your answer should be compact. 0.87. What is the ratio of the Aid flow from DAC donars (current US$) of Poland in 1994 to that in 1997?
Provide a short and direct response. 2.11. What is the ratio of the Aid flow from DAC donars (current US$) of Europe(developing only) in 1994 to that in 1998?
Make the answer very short. 0.98. What is the ratio of the Aid flow from DAC donars (current US$) of Macao in 1994 to that in 1998?
Make the answer very short. 0.54. What is the ratio of the Aid flow from DAC donars (current US$) of Poland in 1994 to that in 1998?
Provide a short and direct response. 2.07. What is the ratio of the Aid flow from DAC donars (current US$) in Europe(developing only) in 1995 to that in 1996?
Ensure brevity in your answer.  0.98. What is the ratio of the Aid flow from DAC donars (current US$) of Macao in 1995 to that in 1996?
Your response must be concise. 0.48. What is the ratio of the Aid flow from DAC donars (current US$) of Poland in 1995 to that in 1996?
Offer a very short reply. 3.26. What is the ratio of the Aid flow from DAC donars (current US$) in Europe(developing only) in 1995 to that in 1997?
Make the answer very short. 1.13. What is the ratio of the Aid flow from DAC donars (current US$) of Macao in 1995 to that in 1997?
Keep it short and to the point. 0.45. What is the ratio of the Aid flow from DAC donars (current US$) of Poland in 1995 to that in 1997?
Ensure brevity in your answer.  4.41. What is the ratio of the Aid flow from DAC donars (current US$) of Europe(developing only) in 1995 to that in 1998?
Your response must be concise. 0.91. What is the ratio of the Aid flow from DAC donars (current US$) of Macao in 1995 to that in 1998?
Make the answer very short. 0.28. What is the ratio of the Aid flow from DAC donars (current US$) in Poland in 1995 to that in 1998?
Your answer should be very brief. 4.35. What is the ratio of the Aid flow from DAC donars (current US$) in Europe(developing only) in 1996 to that in 1997?
Keep it short and to the point. 1.15. What is the ratio of the Aid flow from DAC donars (current US$) in Macao in 1996 to that in 1997?
Your response must be concise. 0.94. What is the ratio of the Aid flow from DAC donars (current US$) in Poland in 1996 to that in 1997?
Your answer should be very brief. 1.35. What is the ratio of the Aid flow from DAC donars (current US$) of Europe(developing only) in 1996 to that in 1998?
Offer a very short reply. 0.93. What is the ratio of the Aid flow from DAC donars (current US$) of Macao in 1996 to that in 1998?
Provide a succinct answer. 0.58. What is the ratio of the Aid flow from DAC donars (current US$) in Poland in 1996 to that in 1998?
Your answer should be compact. 1.33. What is the ratio of the Aid flow from DAC donars (current US$) of Europe(developing only) in 1997 to that in 1998?
Your response must be concise. 0.81. What is the ratio of the Aid flow from DAC donars (current US$) of Macao in 1997 to that in 1998?
Your answer should be very brief. 0.62. What is the ratio of the Aid flow from DAC donars (current US$) of Poland in 1997 to that in 1998?
Ensure brevity in your answer.  0.98. What is the difference between the highest and the second highest Aid flow from DAC donars (current US$) in Europe(developing only)?
Offer a terse response. 5.60e+07. What is the difference between the highest and the second highest Aid flow from DAC donars (current US$) in Poland?
Give a very brief answer. 1.28e+09. What is the difference between the highest and the lowest Aid flow from DAC donars (current US$) of Europe(developing only)?
Your answer should be compact. 1.03e+09. What is the difference between the highest and the lowest Aid flow from DAC donars (current US$) in Macao?
Offer a very short reply. 3.80e+05. What is the difference between the highest and the lowest Aid flow from DAC donars (current US$) of Poland?
Provide a succinct answer. 2.93e+09. 